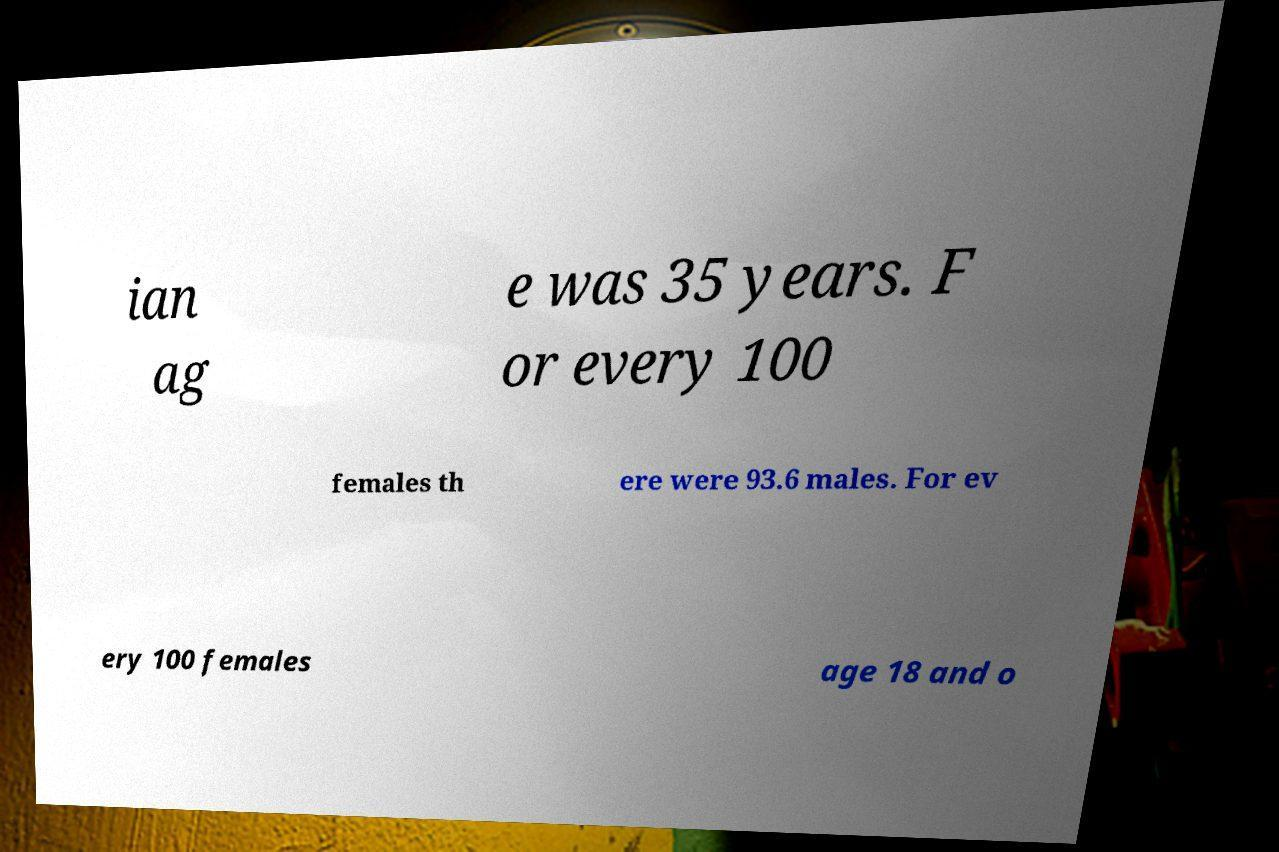Please identify and transcribe the text found in this image. ian ag e was 35 years. F or every 100 females th ere were 93.6 males. For ev ery 100 females age 18 and o 